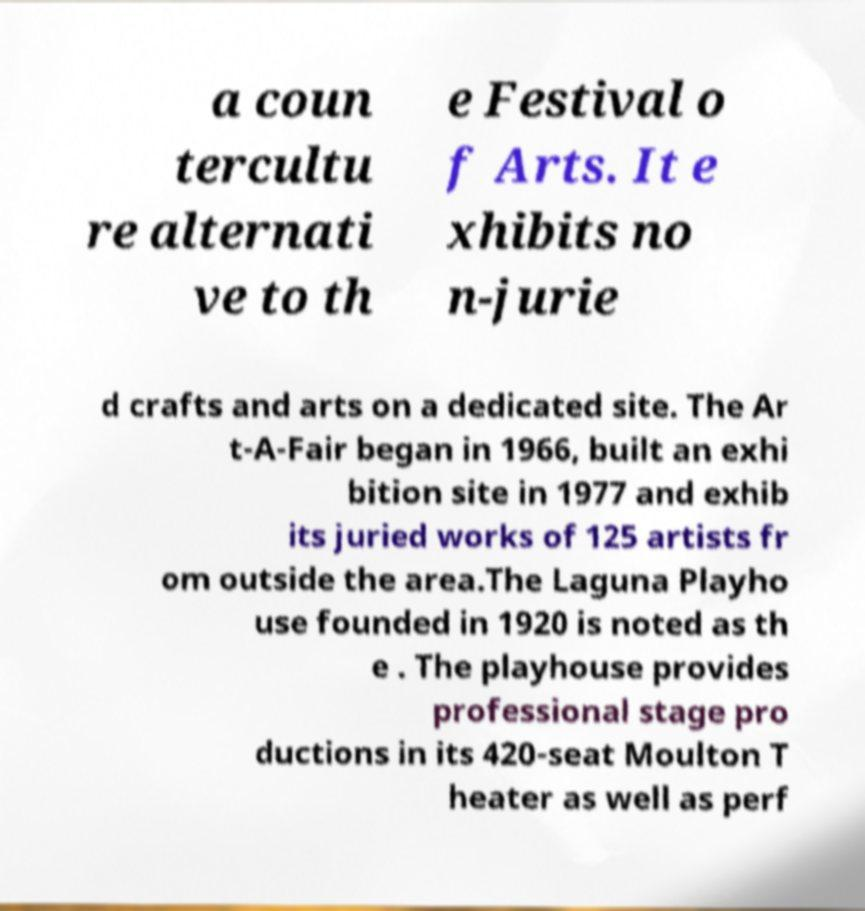Can you read and provide the text displayed in the image?This photo seems to have some interesting text. Can you extract and type it out for me? a coun tercultu re alternati ve to th e Festival o f Arts. It e xhibits no n-jurie d crafts and arts on a dedicated site. The Ar t-A-Fair began in 1966, built an exhi bition site in 1977 and exhib its juried works of 125 artists fr om outside the area.The Laguna Playho use founded in 1920 is noted as th e . The playhouse provides professional stage pro ductions in its 420-seat Moulton T heater as well as perf 